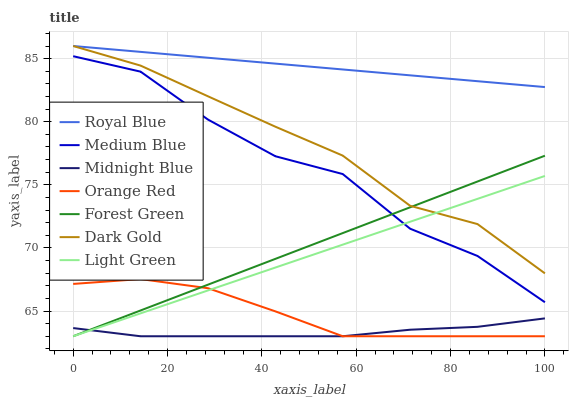Does Dark Gold have the minimum area under the curve?
Answer yes or no. No. Does Dark Gold have the maximum area under the curve?
Answer yes or no. No. Is Dark Gold the smoothest?
Answer yes or no. No. Is Dark Gold the roughest?
Answer yes or no. No. Does Dark Gold have the lowest value?
Answer yes or no. No. Does Medium Blue have the highest value?
Answer yes or no. No. Is Midnight Blue less than Medium Blue?
Answer yes or no. Yes. Is Medium Blue greater than Orange Red?
Answer yes or no. Yes. Does Midnight Blue intersect Medium Blue?
Answer yes or no. No. 